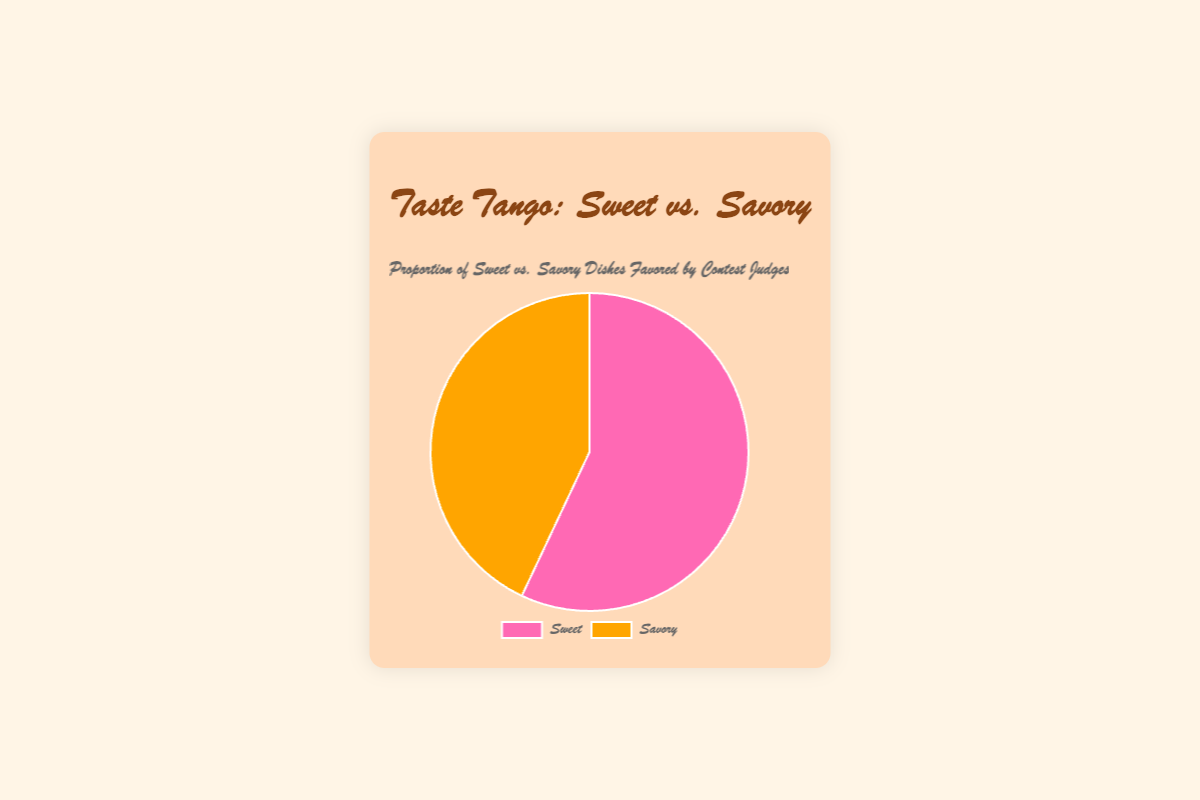what percentage of dishes favored by judges are sweet? The chart shows the data distribution with 57% for sweet dishes.
Answer: 57% Which category of dishes is favored more by the judges? The chart depicts sweet dishes with 57% and savory dishes with 43%. Since 57% is greater than 43%, sweet dishes are favored more.
Answer: Sweet What's the difference in preference percentage between the sweet and savory dishes? The preference percentage for sweet dishes is 57% and for savory dishes is 43%. The difference is calculated by subtracting the smaller percentage from the larger one: 57% - 43% = 14%.
Answer: 14% By how much does the preference for sweet dishes exceed that for savory dishes? To find by how much sweet dishes exceed savory dishes, subtract the percentage of savory dishes from sweet dishes: 57% - 43% = 14%.
Answer: 14% If judges evaluated 100 dishes, how many would be sweet and how many would be savory based on their preferences? If the judges evaluated 100 dishes, the number of sweet dishes evaluated would be 57% of 100, which is 57 dishes. Similarly, the number of savory dishes evaluated would be 43% of 100, which is 43 dishes.
Answer: 57 sweet, 43 savory What can you infer about the judges' culinary tastes based on this pie chart? The pie chart shows that judges favor sweet dishes (57%) more than savory dishes (43%), implying a preference for sweeter flavors in the dishes they judge.
Answer: Preference for sweet What is the total percentage of all categories combined? The pie chart shows two categories: sweet (57%) and savory (43%). Adding these two percentages gives: 57% + 43% = 100%.
Answer: 100% Describe the visual difference in color between the categories representing sweet and savory dishes. In the pie chart, sweet dishes are represented in pink, while savory dishes are represented in orange.
Answer: Pink for sweet, orange for savory 